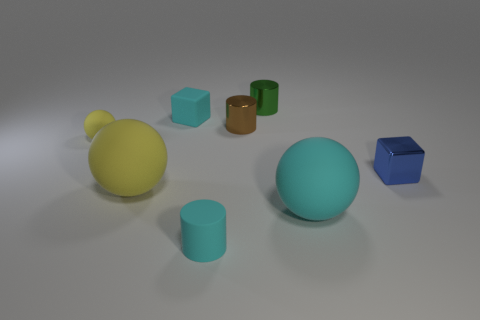What number of tiny matte blocks are the same color as the small matte cylinder?
Your response must be concise. 1. The rubber thing that is right of the tiny cyan cylinder is what color?
Offer a terse response. Cyan. What is the color of the matte cylinder that is the same size as the blue thing?
Provide a succinct answer. Cyan. Is the metal block the same size as the cyan rubber block?
Make the answer very short. Yes. What number of yellow objects are behind the large yellow object?
Make the answer very short. 1. How many things are small blocks on the left side of the tiny cyan rubber cylinder or small blue matte blocks?
Offer a very short reply. 1. Is the number of small shiny objects that are in front of the green metal cylinder greater than the number of tiny cyan things that are right of the brown metallic thing?
Give a very brief answer. Yes. What size is the block that is the same color as the rubber cylinder?
Give a very brief answer. Small. There is a brown metal thing; does it have the same size as the cylinder that is in front of the small rubber ball?
Ensure brevity in your answer.  Yes. What number of cubes are either cyan matte objects or big cyan objects?
Your answer should be compact. 1. 